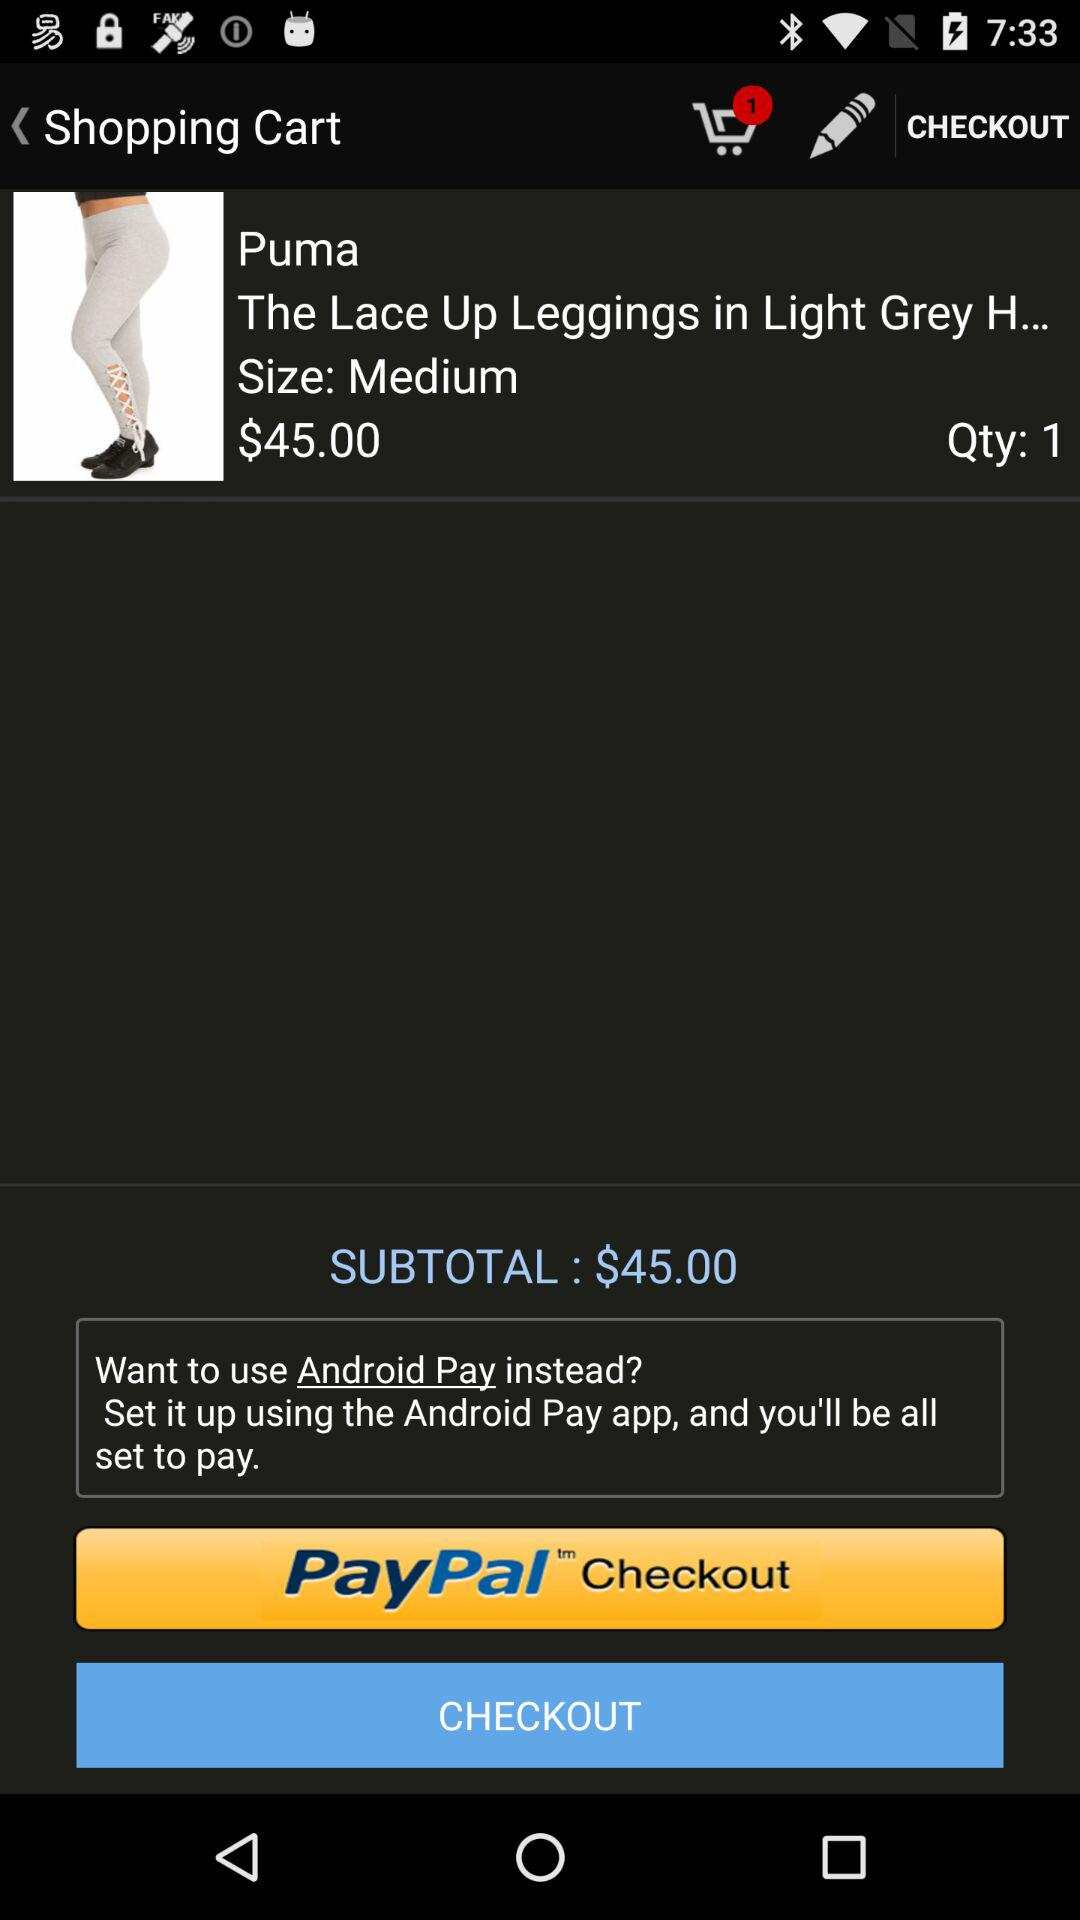What is the subtotal amount? The subtotal amount is $45.00. 